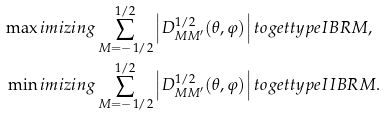Convert formula to latex. <formula><loc_0><loc_0><loc_500><loc_500>\max i m i z i n g & \sum _ { M = - 1 / 2 } ^ { 1 / 2 } \left | D _ { M M ^ { \prime } } ^ { 1 / 2 } ( \theta , \varphi ) \right | t o g e t t y p e I B R M , \\ \min i m i z i n g & \sum _ { M = - 1 / 2 } ^ { 1 / 2 } \left | D _ { M M ^ { \prime } } ^ { 1 / 2 } ( \theta , \varphi ) \right | t o g e t t y p e I I B R M .</formula> 